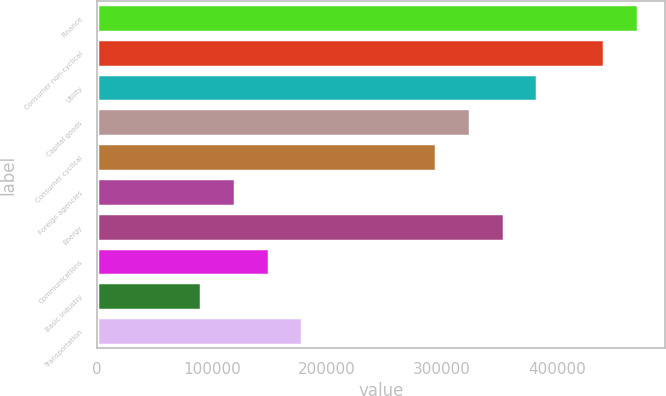<chart> <loc_0><loc_0><loc_500><loc_500><bar_chart><fcel>Finance<fcel>Consumer non-cyclical<fcel>Utility<fcel>Capital goods<fcel>Consumer cyclical<fcel>Foreign agencies<fcel>Energy<fcel>Communications<fcel>Basic industry<fcel>Transportation<nl><fcel>470251<fcel>441061<fcel>382680<fcel>324299<fcel>295109<fcel>119967<fcel>353490<fcel>149157<fcel>90776.2<fcel>178347<nl></chart> 